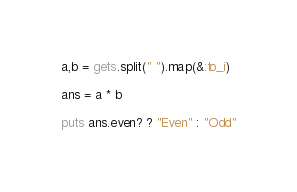<code> <loc_0><loc_0><loc_500><loc_500><_Ruby_>a,b = gets.split(" ").map(&:to_i)
 
ans = a * b
 
puts ans.even? ? "Even" : "Odd"</code> 